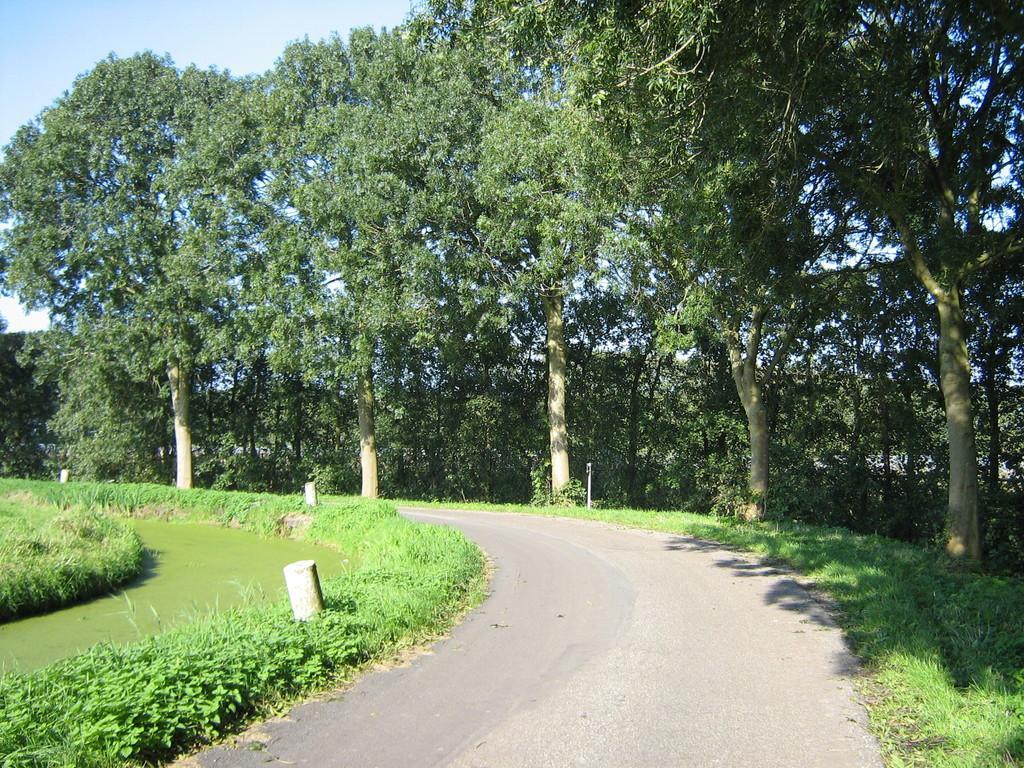How would you summarize this image in a sentence or two? In this image there are small plants and green grass in the left corner. There are trees and green grass in the right corner. There is a road at the bottom. There are trees in the background. And there is a sky at the top. 